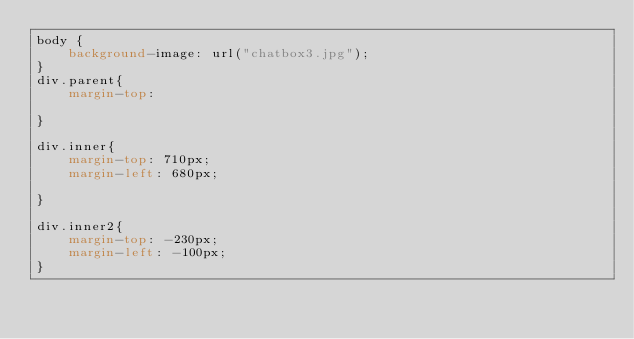<code> <loc_0><loc_0><loc_500><loc_500><_CSS_>body {
	background-image: url("chatbox3.jpg");
}
div.parent{
	margin-top: 

}

div.inner{
	margin-top: 710px;
	margin-left: 680px;

}

div.inner2{
	margin-top: -230px;
	margin-left: -100px; 
}</code> 